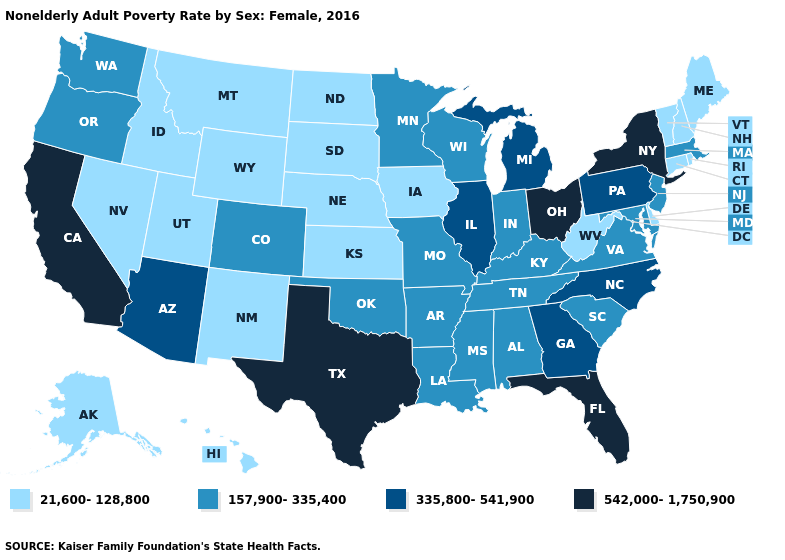Among the states that border Oklahoma , which have the lowest value?
Keep it brief. Kansas, New Mexico. Which states hav the highest value in the West?
Quick response, please. California. Name the states that have a value in the range 21,600-128,800?
Write a very short answer. Alaska, Connecticut, Delaware, Hawaii, Idaho, Iowa, Kansas, Maine, Montana, Nebraska, Nevada, New Hampshire, New Mexico, North Dakota, Rhode Island, South Dakota, Utah, Vermont, West Virginia, Wyoming. Which states hav the highest value in the South?
Short answer required. Florida, Texas. What is the value of Alabama?
Concise answer only. 157,900-335,400. What is the value of Louisiana?
Give a very brief answer. 157,900-335,400. What is the value of Pennsylvania?
Keep it brief. 335,800-541,900. Name the states that have a value in the range 157,900-335,400?
Concise answer only. Alabama, Arkansas, Colorado, Indiana, Kentucky, Louisiana, Maryland, Massachusetts, Minnesota, Mississippi, Missouri, New Jersey, Oklahoma, Oregon, South Carolina, Tennessee, Virginia, Washington, Wisconsin. Name the states that have a value in the range 335,800-541,900?
Keep it brief. Arizona, Georgia, Illinois, Michigan, North Carolina, Pennsylvania. What is the highest value in the Northeast ?
Give a very brief answer. 542,000-1,750,900. Name the states that have a value in the range 542,000-1,750,900?
Short answer required. California, Florida, New York, Ohio, Texas. Name the states that have a value in the range 335,800-541,900?
Short answer required. Arizona, Georgia, Illinois, Michigan, North Carolina, Pennsylvania. What is the value of New Hampshire?
Quick response, please. 21,600-128,800. Which states have the lowest value in the USA?
Concise answer only. Alaska, Connecticut, Delaware, Hawaii, Idaho, Iowa, Kansas, Maine, Montana, Nebraska, Nevada, New Hampshire, New Mexico, North Dakota, Rhode Island, South Dakota, Utah, Vermont, West Virginia, Wyoming. Does Oregon have the lowest value in the West?
Give a very brief answer. No. 